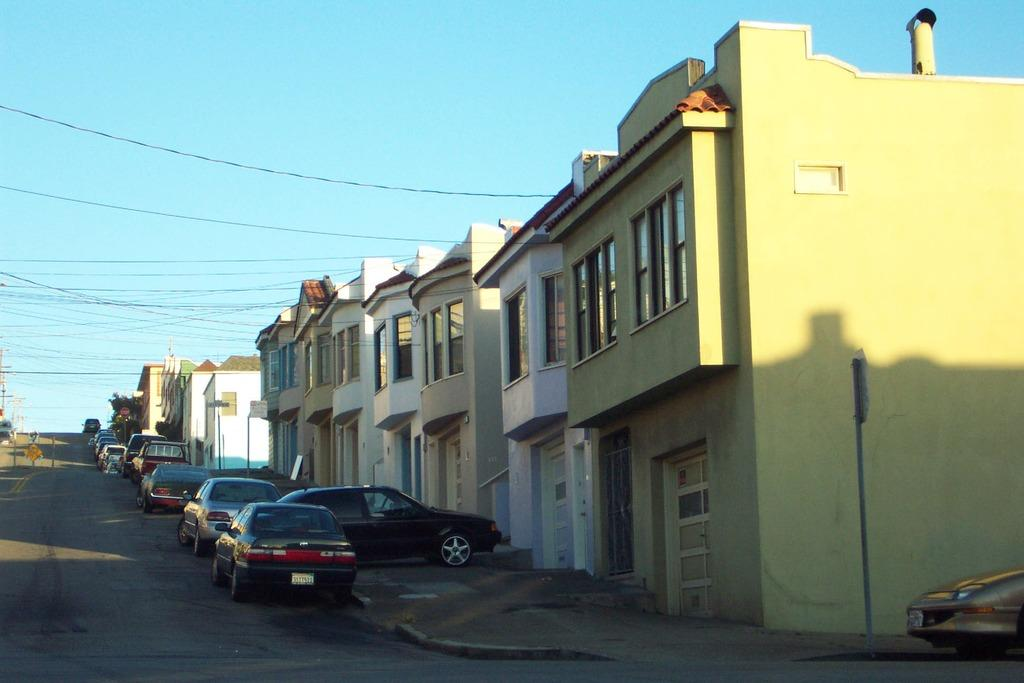What can be seen in the center of the image? There are cars and houses in the center of the image, along with cables. What is on the left side of the image? There is a road on the left side of the image. What is on the right side of the image? There is a car and a pole on the right side of the image. How is the weather in the image? The weather is sunny in the image. Where is the cub playing with a button in the image? There is no cub or button present in the image. How does the twist in the cables affect the cars in the image? There is no twist in the cables mentioned in the image, and the cars are not affected by any twists. 